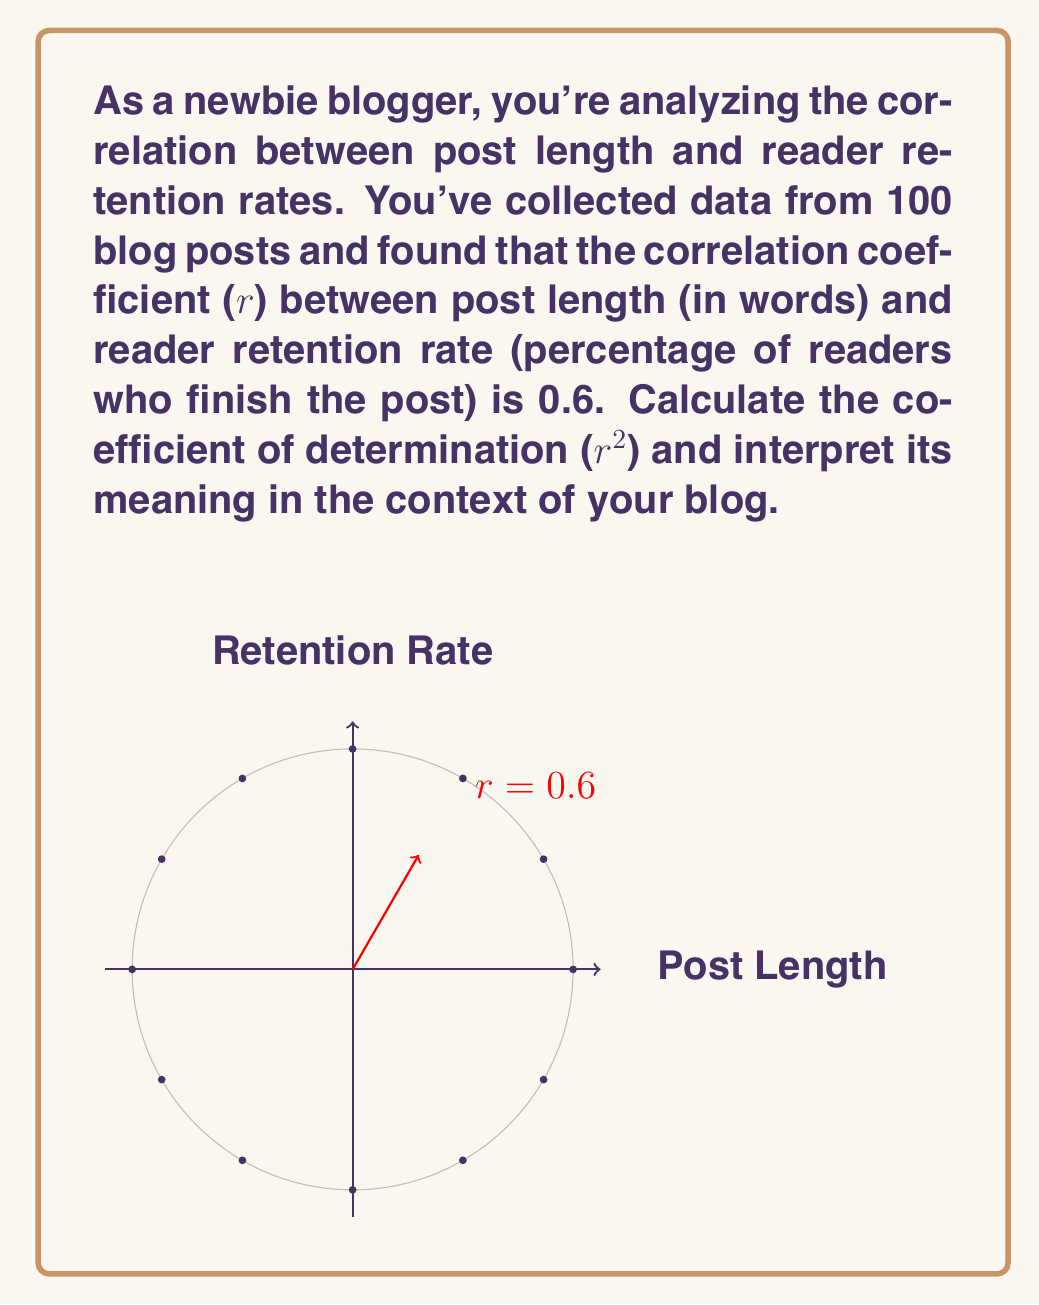Show me your answer to this math problem. To solve this problem, we'll follow these steps:

1) The coefficient of determination (r²) is the square of the correlation coefficient (r).

2) Given:
   Correlation coefficient (r) = 0.6

3) Calculate r²:
   $$r^2 = (0.6)^2 = 0.36$$

4) Interpretation:
   The coefficient of determination (r²) represents the proportion of the variance in the dependent variable (reader retention rate) that is predictable from the independent variable (post length).

   In this case, r² = 0.36 means that 36% of the variance in reader retention rates can be explained by the variation in post length.

5) For your blog, this means:
   - 36% of the changes in how many readers finish your posts can be attributed to the length of your posts.
   - The remaining 64% of the variation in retention rates is due to other factors not accounted for in this analysis (e.g., content quality, writing style, topic interest).

6) This moderate positive correlation suggests that longer posts tend to have slightly higher retention rates, but post length alone doesn't determine reader retention. As a newbie blogger, you should consider post length as one factor among many in engaging your readers.
Answer: r² = 0.36; 36% of retention rate variance explained by post length 